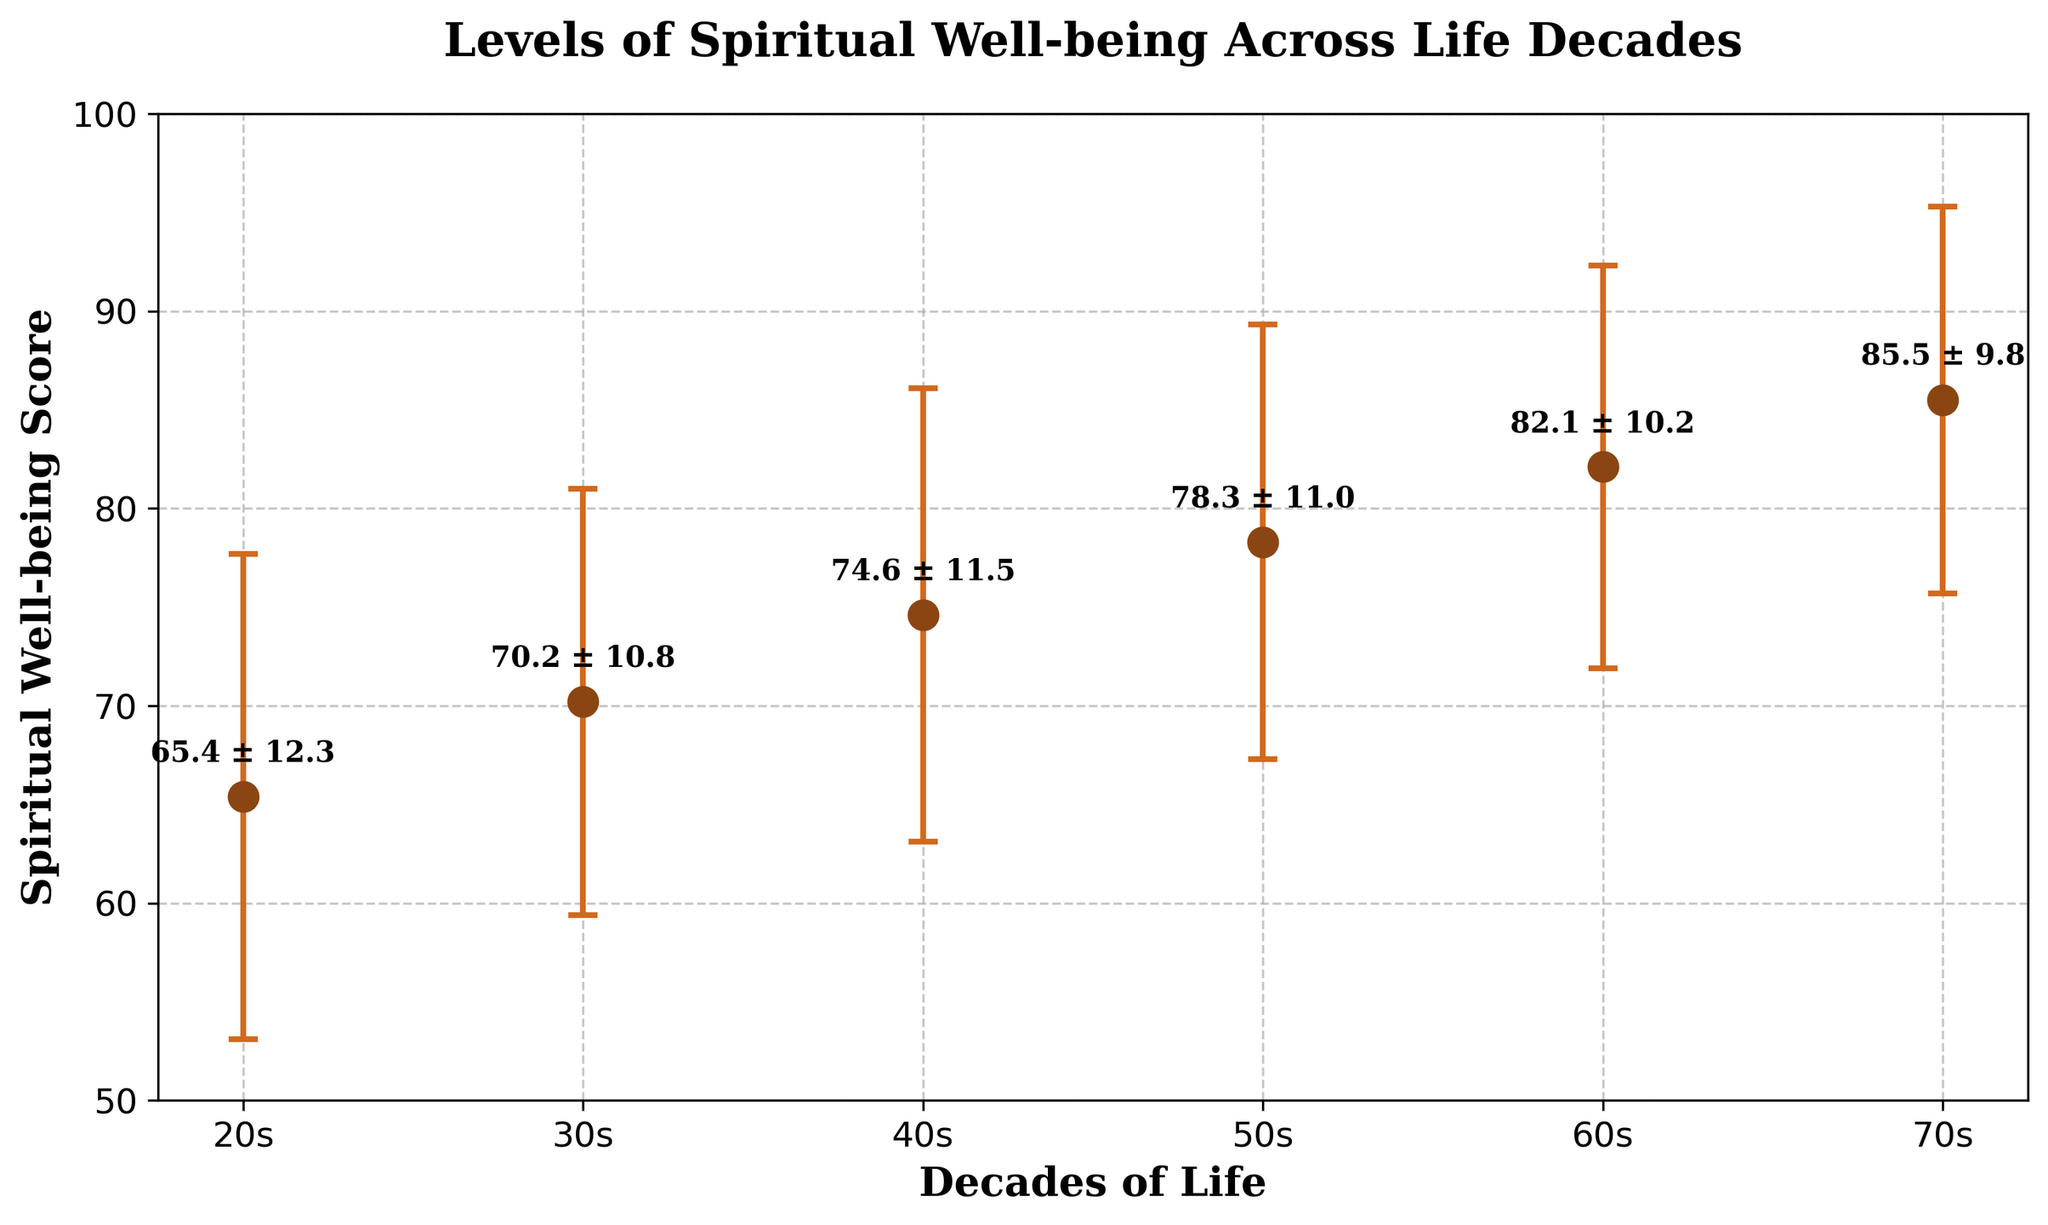What is the title of the figure? The title of the figure is written at the top and usually describes the main theme or focus of the plot.
Answer: Levels of Spiritual Well-being Across Life Decades What does the x-axis represent? The x-axis label is provided below the axis and indicates what type of data is being plotted along the horizontal axis.
Answer: Decades of Life How many data points are plotted in the figure? The number of data points can be counted from the number of points along the x-axis. Each point corresponds to a different decade of life.
Answer: 6 What is the mean spiritual well-being score for people in their 50s? This value is found at the point where the '50s' decade is plotted. The mean is indicated by the central point of the error bar for that decade.
Answer: 78.3 Which decade has the highest mean spiritual well-being score? To determine this, compare the heights of the plotted points for each decade. The highest point represents the highest mean score.
Answer: 70s What is the improvement in mean spiritual well-being score from the 20s to the 60s? To calculate the improvement, subtract the mean score of the 20s from the mean score of the 60s: 82.1 - 65.4.
Answer: 16.7 Between which two consecutive decades is the increase in mean spiritual well-being score the smallest? To find this, calculate the difference in mean scores between each pair of consecutive decades and identify the smallest difference.
Answer: 50s to 60s What is the standard deviation of the spiritual well-being score for the 30s? This value can be found at the point corresponding to the '30s' decade, usually displayed as a label or error bar.
Answer: 10.8 Which decade shows the greatest variability in spiritual well-being? Variability is indicated by the length of the error bars. The decade with the longest error bar has the greatest variability.
Answer: 20s How does the standard deviation change as the mean spiritual well-being score increases across decades? Observing the trend in error bars along with the increasing mean scores can reveal the pattern in standard deviation changes.
Answer: Generally decreases 